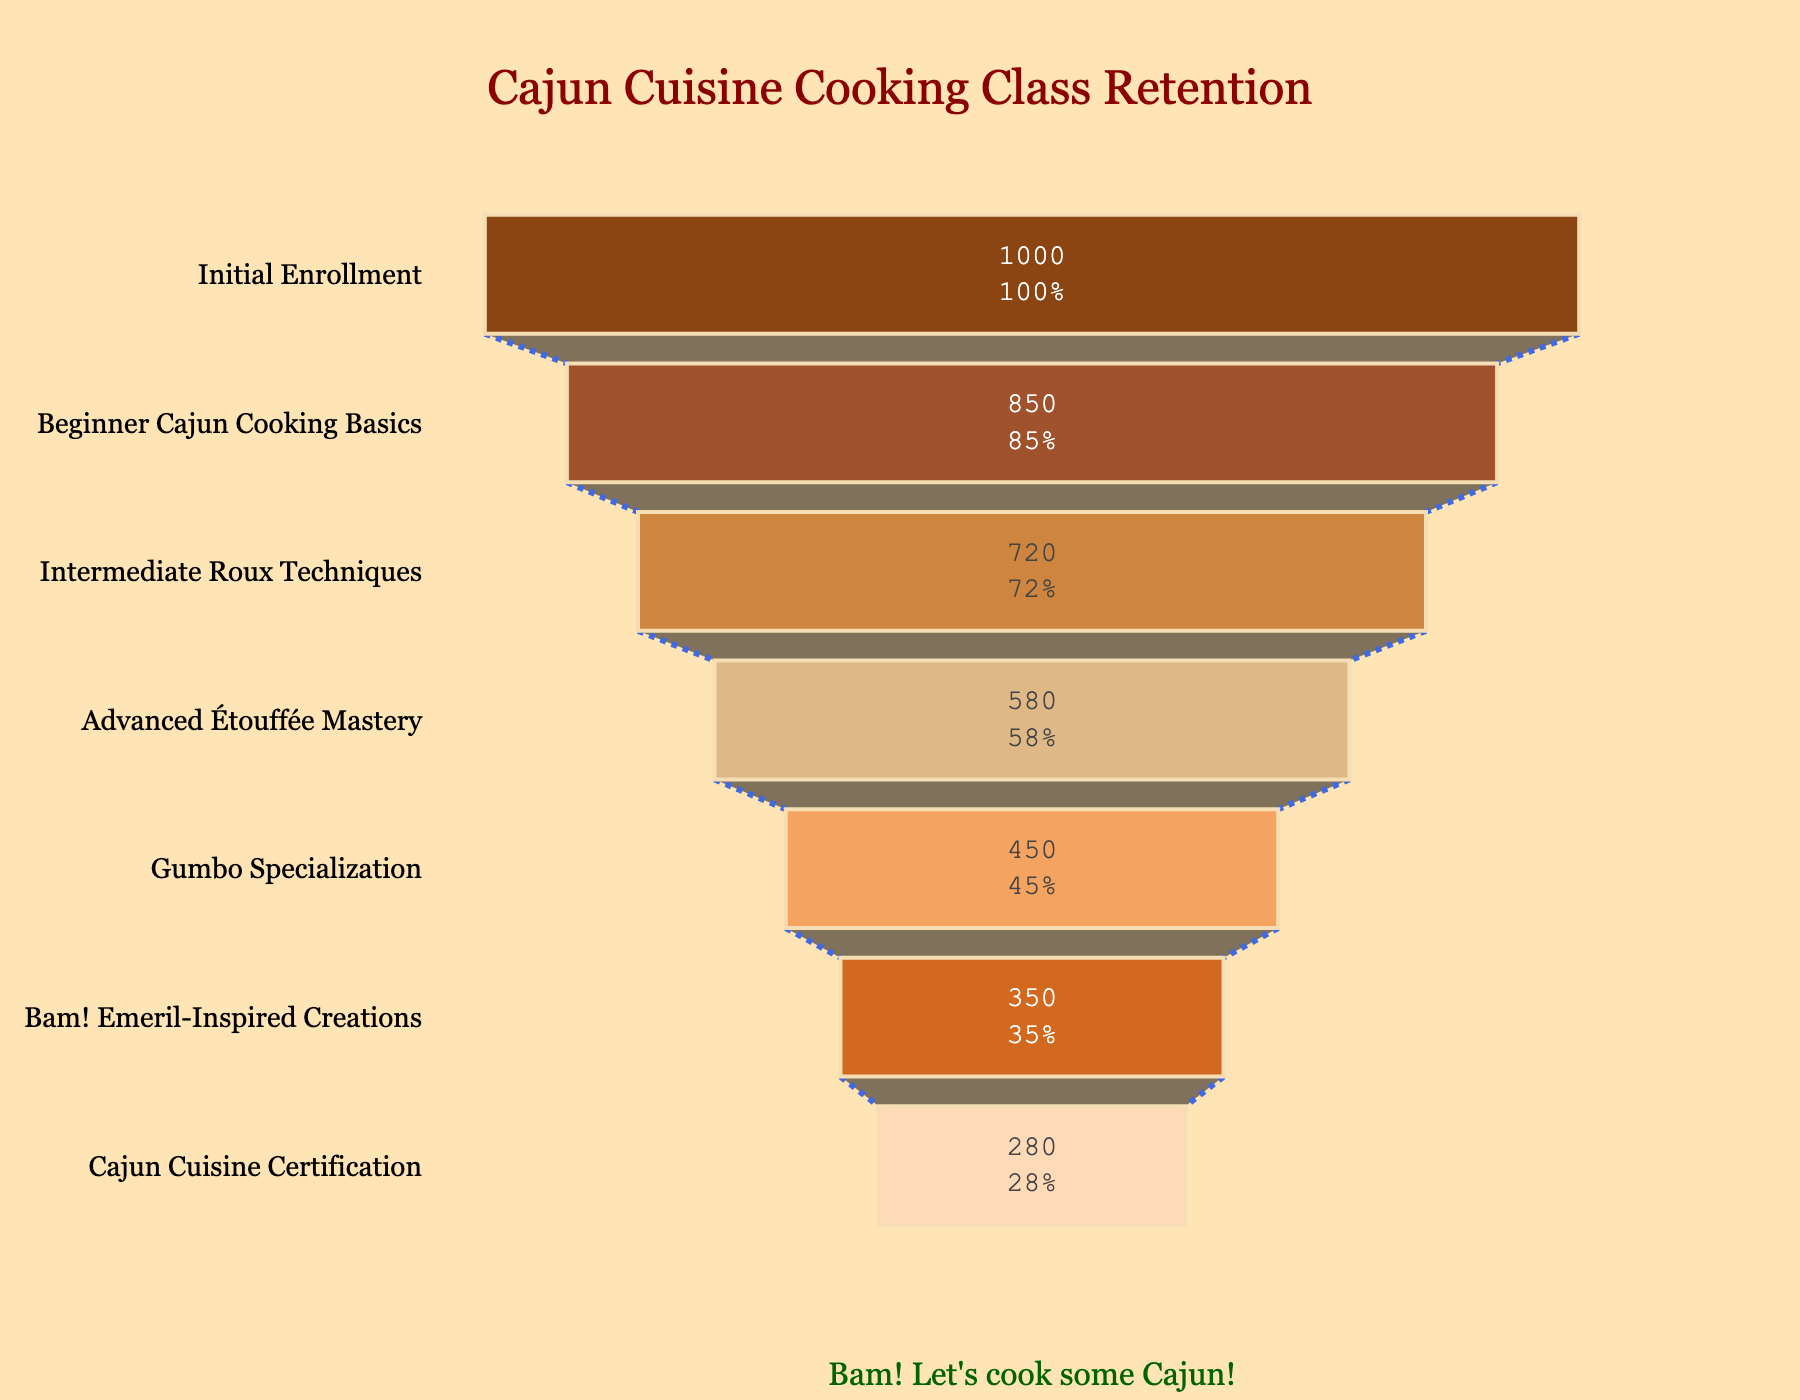What's the title of the figure? The title is located at the top of the chart and is formatted in a notable size and color for clarity.
Answer: Cajun Cuisine Cooking Class Retention What stage has the most significant drop in student numbers? To find this, look for the stage transition with the most considerable reduction in the width of the funnel. Subtract the number of students at each subsequent stage to find the largest difference.
Answer: Beginner Cajun Cooking Basics to Intermediate Roux Techniques How many students completed the Advanced Étouffée Mastery stage? The number of students is located on the bar labeled 'Advanced Étouffée Mastery' within the funnel chart.
Answer: 580 What's the percentage of students who reached the Cajun Cuisine Certification stage from the initial enrollment? To calculate this, divide the number of students at the final stage by the initial enrollment and multiply by 100. (280/1000)*100 = 28%
Answer: 28% Which stages have fewer than 500 students? Identify stages by noting their corresponding student numbers. Compare each number to 500 and list those stages.
Answer: Gumbo Specialization, Bam! Emeril-Inspired Creations, Cajun Cuisine Certification What is the cumulative number of students progressing from Intermediate Roux Techniques to the end? Sum the number of students in the stages starting from Intermediate Roux Techniques to the Cajun Cuisine Certification stage. 720 (Intermediate Roux Techniques) + 580 + 450 + 350 + 280 = 2380
Answer: 2380 What percentage of students dropped out before reaching the Gumbo Specialization stage? First, identify the number of students at the stage right before Gumbo Specialization. Then subtract the number of students at that stage from initial enrollment and divide by the initial enrollment, finally multiply by 100. ((1000 - 450) / 1000) * 100 = 55%
Answer: 55% Which stage contributes the highest percentage of retention from the previous stage? To find this, calculate the percentage retention for each stage by dividing the number of students at a stage by the number at its previous stage and identify the highest value.
Answer: Advanced Étouffée Mastery from Intermediate Roux Techniques By how many students did the attendance decrease from Advanced Étouffée Mastery to Gumbo Specialization? Subtract the number of students in the Gumbo Specialization stage from that in the Advanced Étouffée Mastery stage. 580 - 450 = 130
Answer: 130 What proportion of the initially enrolled students complete the Bam! Emeril-Inspired Creations stage? Divide the number of students in the Bam! Emeril-Inspired Creations stage by the initial enrollment and multiply by 100 to get the percentage. (350/1000) * 100 = 35%
Answer: 35% 